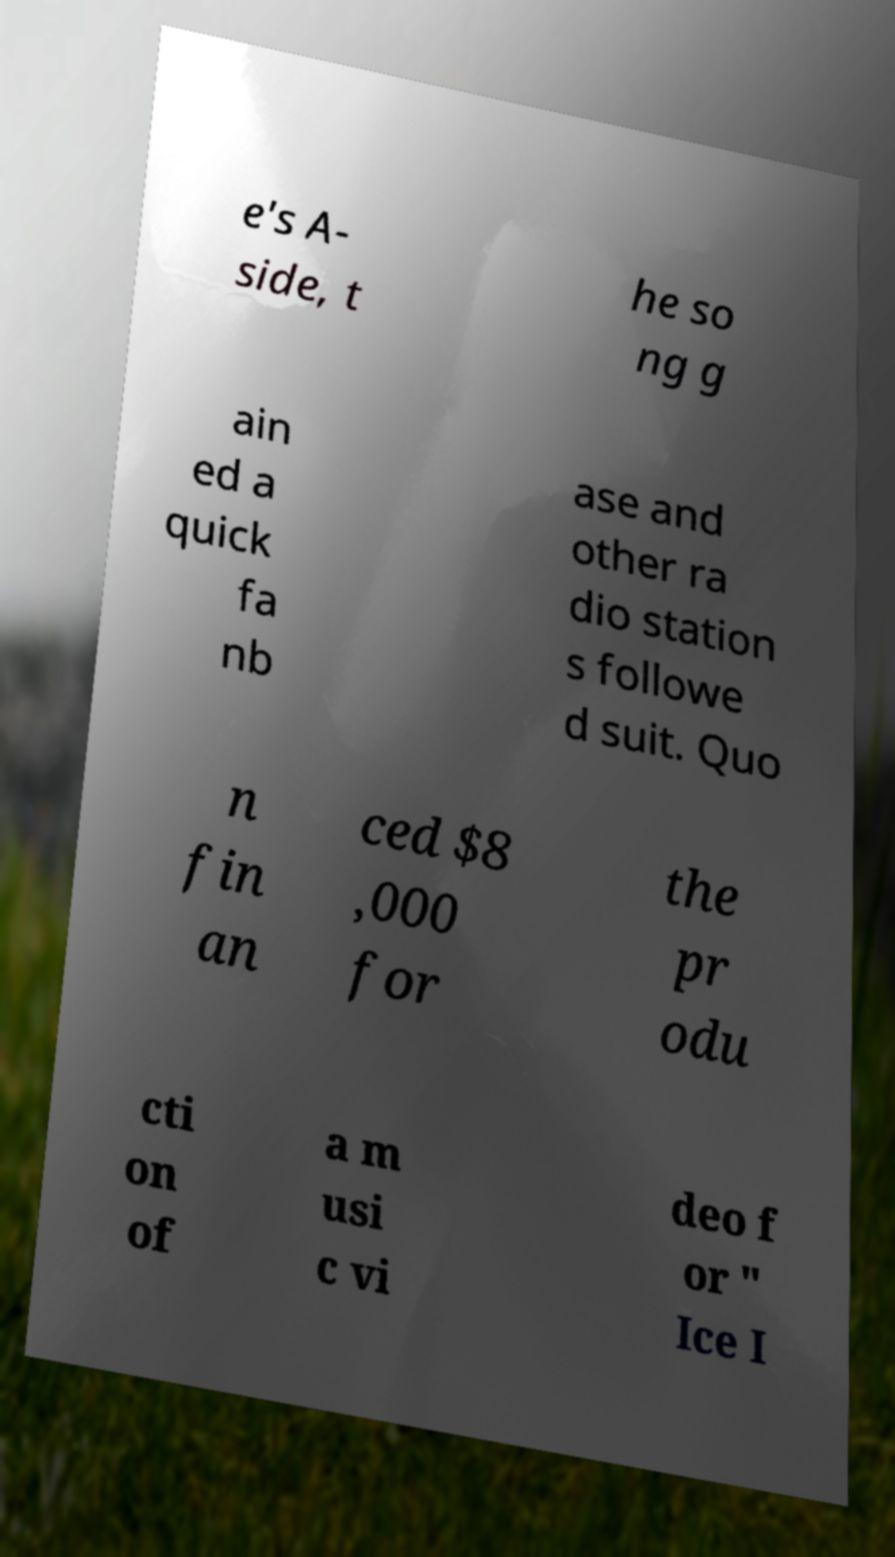Please read and relay the text visible in this image. What does it say? e's A- side, t he so ng g ain ed a quick fa nb ase and other ra dio station s followe d suit. Quo n fin an ced $8 ,000 for the pr odu cti on of a m usi c vi deo f or " Ice I 